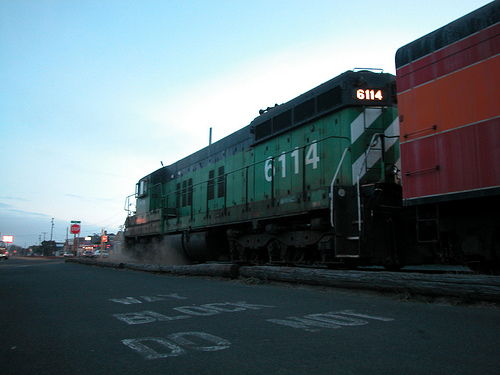Describe a short realistic scenario involving the train. The train is on its daily route, carrying freight from one city to another. As it passes through the town, it momentarily halts at a crossing, allowing pedestrians and vehicles to clear before continuing on its journey. The city lights begin to flicker on as evening falls. A train conductor peers out the window, making sure all is clear, and with a final blow of the horn, the train resumes its journey into the night. 